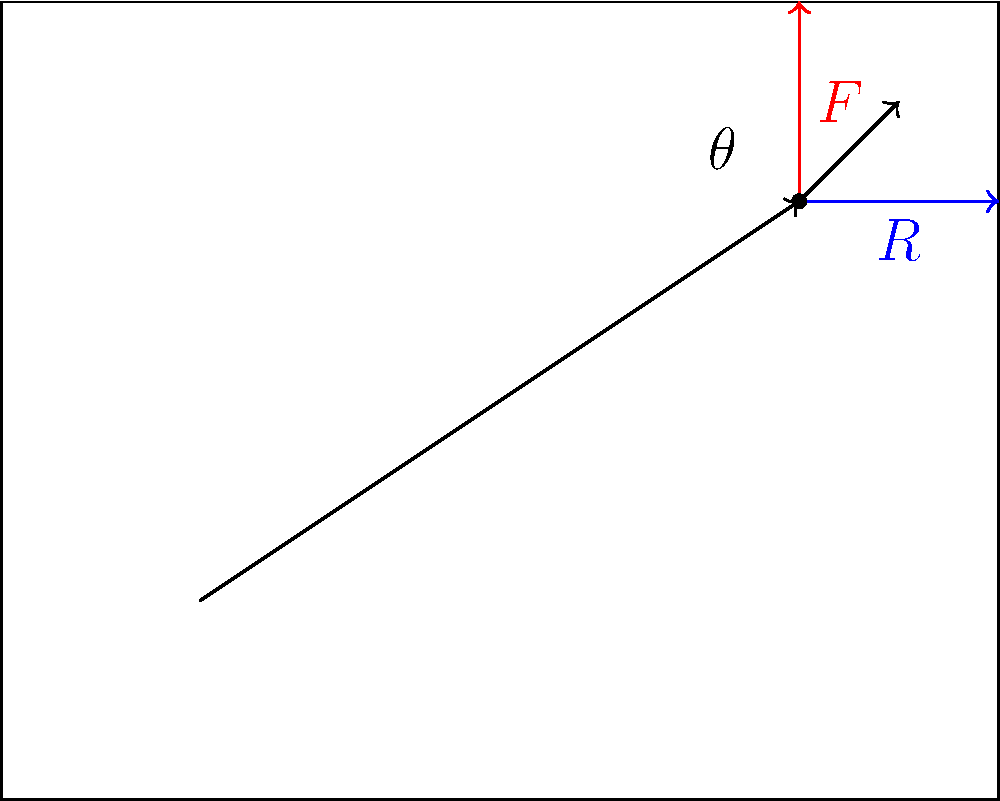In a piano hammer mechanism, the hammer strikes the string with a force $F$ at an angle $\theta$ to the vertical. If the reaction force $R$ from the string is horizontal, derive an expression for $R$ in terms of $F$ and $\theta$. How might this relationship influence the tonal quality of a therapeutic composition? To solve this problem, we'll follow these steps:

1) First, we need to understand that the forces acting on the hammer at the point of contact form a right-angled triangle.

2) We can resolve the force $F$ into its vertical and horizontal components:
   - Vertical component: $F \cos\theta$
   - Horizontal component: $F \sin\theta$

3) At equilibrium, the horizontal component of $F$ must be equal and opposite to the reaction force $R$:

   $R = F \sin\theta$

4) This equation shows that the reaction force $R$ is directly proportional to both the striking force $F$ and the sine of the angle $\theta$.

5) In terms of therapeutic composition:
   - A larger $\theta$ (for the same $F$) would result in a larger $R$, potentially producing a brighter, more energetic tone.
   - A smaller $\theta$ would result in a smaller $R$, potentially producing a softer, more mellow tone.
   - Varying $\theta$ throughout a composition could create a range of tonal colors, which could be used to evoke different emotional responses in therapy.

6) The composer could use this knowledge to carefully design the tonal progression of a therapeutic piece, tailoring the sound to specific therapeutic goals.
Answer: $R = F \sin\theta$ 